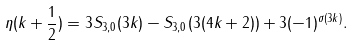Convert formula to latex. <formula><loc_0><loc_0><loc_500><loc_500>\eta ( k + \frac { 1 } { 2 } ) = 3 S _ { 3 , 0 } ( 3 k ) - S _ { 3 , 0 } ( 3 ( 4 k + 2 ) ) + 3 ( - 1 ) ^ { \sigma ( 3 k ) } .</formula> 